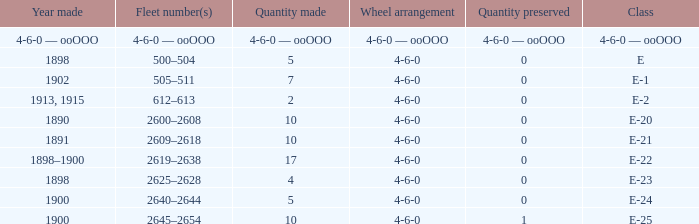What is the quantity made of the e-22 class, which has a quantity preserved of 0? 17.0. 